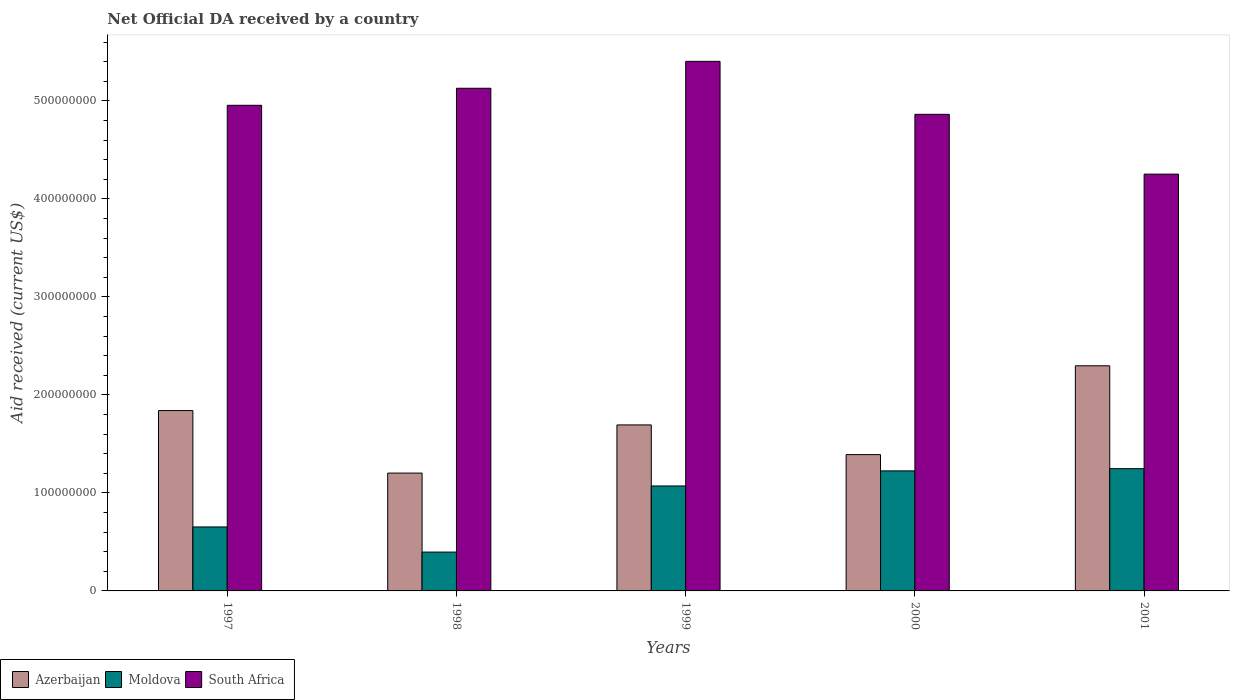Are the number of bars per tick equal to the number of legend labels?
Your response must be concise. Yes. Are the number of bars on each tick of the X-axis equal?
Offer a terse response. Yes. In how many cases, is the number of bars for a given year not equal to the number of legend labels?
Ensure brevity in your answer.  0. What is the net official development assistance aid received in Azerbaijan in 1997?
Provide a succinct answer. 1.84e+08. Across all years, what is the maximum net official development assistance aid received in South Africa?
Offer a very short reply. 5.40e+08. Across all years, what is the minimum net official development assistance aid received in South Africa?
Your answer should be compact. 4.25e+08. What is the total net official development assistance aid received in South Africa in the graph?
Your answer should be very brief. 2.46e+09. What is the difference between the net official development assistance aid received in Moldova in 1999 and that in 2001?
Give a very brief answer. -1.76e+07. What is the difference between the net official development assistance aid received in Moldova in 2001 and the net official development assistance aid received in South Africa in 1999?
Give a very brief answer. -4.16e+08. What is the average net official development assistance aid received in South Africa per year?
Provide a short and direct response. 4.92e+08. In the year 1998, what is the difference between the net official development assistance aid received in South Africa and net official development assistance aid received in Azerbaijan?
Keep it short and to the point. 3.93e+08. What is the ratio of the net official development assistance aid received in South Africa in 1999 to that in 2000?
Your response must be concise. 1.11. Is the net official development assistance aid received in Moldova in 2000 less than that in 2001?
Give a very brief answer. Yes. Is the difference between the net official development assistance aid received in South Africa in 1997 and 2001 greater than the difference between the net official development assistance aid received in Azerbaijan in 1997 and 2001?
Give a very brief answer. Yes. What is the difference between the highest and the second highest net official development assistance aid received in Moldova?
Your response must be concise. 2.26e+06. What is the difference between the highest and the lowest net official development assistance aid received in Azerbaijan?
Your answer should be compact. 1.10e+08. Is the sum of the net official development assistance aid received in Moldova in 1997 and 1999 greater than the maximum net official development assistance aid received in Azerbaijan across all years?
Provide a succinct answer. No. What does the 1st bar from the left in 2001 represents?
Provide a short and direct response. Azerbaijan. What does the 3rd bar from the right in 1999 represents?
Give a very brief answer. Azerbaijan. How many bars are there?
Offer a terse response. 15. Are all the bars in the graph horizontal?
Your answer should be compact. No. How many years are there in the graph?
Offer a terse response. 5. Are the values on the major ticks of Y-axis written in scientific E-notation?
Your answer should be compact. No. Does the graph contain any zero values?
Your answer should be compact. No. What is the title of the graph?
Your answer should be very brief. Net Official DA received by a country. Does "Cabo Verde" appear as one of the legend labels in the graph?
Provide a succinct answer. No. What is the label or title of the X-axis?
Your answer should be very brief. Years. What is the label or title of the Y-axis?
Make the answer very short. Aid received (current US$). What is the Aid received (current US$) in Azerbaijan in 1997?
Provide a succinct answer. 1.84e+08. What is the Aid received (current US$) of Moldova in 1997?
Provide a short and direct response. 6.53e+07. What is the Aid received (current US$) in South Africa in 1997?
Your answer should be compact. 4.96e+08. What is the Aid received (current US$) of Azerbaijan in 1998?
Provide a succinct answer. 1.20e+08. What is the Aid received (current US$) of Moldova in 1998?
Offer a very short reply. 3.96e+07. What is the Aid received (current US$) of South Africa in 1998?
Provide a succinct answer. 5.13e+08. What is the Aid received (current US$) in Azerbaijan in 1999?
Keep it short and to the point. 1.69e+08. What is the Aid received (current US$) of Moldova in 1999?
Your response must be concise. 1.07e+08. What is the Aid received (current US$) of South Africa in 1999?
Offer a very short reply. 5.40e+08. What is the Aid received (current US$) of Azerbaijan in 2000?
Make the answer very short. 1.39e+08. What is the Aid received (current US$) of Moldova in 2000?
Offer a very short reply. 1.22e+08. What is the Aid received (current US$) of South Africa in 2000?
Keep it short and to the point. 4.86e+08. What is the Aid received (current US$) of Azerbaijan in 2001?
Provide a short and direct response. 2.30e+08. What is the Aid received (current US$) in Moldova in 2001?
Your answer should be compact. 1.25e+08. What is the Aid received (current US$) in South Africa in 2001?
Provide a succinct answer. 4.25e+08. Across all years, what is the maximum Aid received (current US$) of Azerbaijan?
Provide a short and direct response. 2.30e+08. Across all years, what is the maximum Aid received (current US$) of Moldova?
Your answer should be compact. 1.25e+08. Across all years, what is the maximum Aid received (current US$) in South Africa?
Make the answer very short. 5.40e+08. Across all years, what is the minimum Aid received (current US$) in Azerbaijan?
Provide a short and direct response. 1.20e+08. Across all years, what is the minimum Aid received (current US$) of Moldova?
Provide a short and direct response. 3.96e+07. Across all years, what is the minimum Aid received (current US$) of South Africa?
Give a very brief answer. 4.25e+08. What is the total Aid received (current US$) of Azerbaijan in the graph?
Provide a short and direct response. 8.43e+08. What is the total Aid received (current US$) in Moldova in the graph?
Make the answer very short. 4.59e+08. What is the total Aid received (current US$) in South Africa in the graph?
Give a very brief answer. 2.46e+09. What is the difference between the Aid received (current US$) in Azerbaijan in 1997 and that in 1998?
Offer a very short reply. 6.38e+07. What is the difference between the Aid received (current US$) of Moldova in 1997 and that in 1998?
Your answer should be compact. 2.57e+07. What is the difference between the Aid received (current US$) of South Africa in 1997 and that in 1998?
Offer a terse response. -1.74e+07. What is the difference between the Aid received (current US$) in Azerbaijan in 1997 and that in 1999?
Make the answer very short. 1.46e+07. What is the difference between the Aid received (current US$) in Moldova in 1997 and that in 1999?
Your response must be concise. -4.18e+07. What is the difference between the Aid received (current US$) in South Africa in 1997 and that in 1999?
Make the answer very short. -4.48e+07. What is the difference between the Aid received (current US$) of Azerbaijan in 1997 and that in 2000?
Offer a very short reply. 4.49e+07. What is the difference between the Aid received (current US$) in Moldova in 1997 and that in 2000?
Your answer should be compact. -5.72e+07. What is the difference between the Aid received (current US$) in South Africa in 1997 and that in 2000?
Keep it short and to the point. 9.22e+06. What is the difference between the Aid received (current US$) in Azerbaijan in 1997 and that in 2001?
Keep it short and to the point. -4.57e+07. What is the difference between the Aid received (current US$) in Moldova in 1997 and that in 2001?
Keep it short and to the point. -5.95e+07. What is the difference between the Aid received (current US$) of South Africa in 1997 and that in 2001?
Make the answer very short. 7.02e+07. What is the difference between the Aid received (current US$) of Azerbaijan in 1998 and that in 1999?
Ensure brevity in your answer.  -4.92e+07. What is the difference between the Aid received (current US$) in Moldova in 1998 and that in 1999?
Your answer should be compact. -6.75e+07. What is the difference between the Aid received (current US$) in South Africa in 1998 and that in 1999?
Provide a succinct answer. -2.75e+07. What is the difference between the Aid received (current US$) in Azerbaijan in 1998 and that in 2000?
Give a very brief answer. -1.89e+07. What is the difference between the Aid received (current US$) of Moldova in 1998 and that in 2000?
Offer a very short reply. -8.29e+07. What is the difference between the Aid received (current US$) of South Africa in 1998 and that in 2000?
Give a very brief answer. 2.66e+07. What is the difference between the Aid received (current US$) of Azerbaijan in 1998 and that in 2001?
Your answer should be compact. -1.10e+08. What is the difference between the Aid received (current US$) of Moldova in 1998 and that in 2001?
Offer a very short reply. -8.51e+07. What is the difference between the Aid received (current US$) in South Africa in 1998 and that in 2001?
Provide a short and direct response. 8.76e+07. What is the difference between the Aid received (current US$) of Azerbaijan in 1999 and that in 2000?
Provide a short and direct response. 3.03e+07. What is the difference between the Aid received (current US$) in Moldova in 1999 and that in 2000?
Keep it short and to the point. -1.54e+07. What is the difference between the Aid received (current US$) of South Africa in 1999 and that in 2000?
Offer a very short reply. 5.41e+07. What is the difference between the Aid received (current US$) of Azerbaijan in 1999 and that in 2001?
Offer a very short reply. -6.03e+07. What is the difference between the Aid received (current US$) in Moldova in 1999 and that in 2001?
Provide a succinct answer. -1.76e+07. What is the difference between the Aid received (current US$) of South Africa in 1999 and that in 2001?
Offer a terse response. 1.15e+08. What is the difference between the Aid received (current US$) in Azerbaijan in 2000 and that in 2001?
Provide a short and direct response. -9.06e+07. What is the difference between the Aid received (current US$) of Moldova in 2000 and that in 2001?
Your response must be concise. -2.26e+06. What is the difference between the Aid received (current US$) of South Africa in 2000 and that in 2001?
Your response must be concise. 6.10e+07. What is the difference between the Aid received (current US$) in Azerbaijan in 1997 and the Aid received (current US$) in Moldova in 1998?
Your answer should be very brief. 1.44e+08. What is the difference between the Aid received (current US$) in Azerbaijan in 1997 and the Aid received (current US$) in South Africa in 1998?
Ensure brevity in your answer.  -3.29e+08. What is the difference between the Aid received (current US$) in Moldova in 1997 and the Aid received (current US$) in South Africa in 1998?
Give a very brief answer. -4.48e+08. What is the difference between the Aid received (current US$) in Azerbaijan in 1997 and the Aid received (current US$) in Moldova in 1999?
Offer a terse response. 7.70e+07. What is the difference between the Aid received (current US$) of Azerbaijan in 1997 and the Aid received (current US$) of South Africa in 1999?
Make the answer very short. -3.56e+08. What is the difference between the Aid received (current US$) in Moldova in 1997 and the Aid received (current US$) in South Africa in 1999?
Give a very brief answer. -4.75e+08. What is the difference between the Aid received (current US$) in Azerbaijan in 1997 and the Aid received (current US$) in Moldova in 2000?
Provide a short and direct response. 6.16e+07. What is the difference between the Aid received (current US$) in Azerbaijan in 1997 and the Aid received (current US$) in South Africa in 2000?
Keep it short and to the point. -3.02e+08. What is the difference between the Aid received (current US$) in Moldova in 1997 and the Aid received (current US$) in South Africa in 2000?
Provide a short and direct response. -4.21e+08. What is the difference between the Aid received (current US$) of Azerbaijan in 1997 and the Aid received (current US$) of Moldova in 2001?
Your response must be concise. 5.93e+07. What is the difference between the Aid received (current US$) in Azerbaijan in 1997 and the Aid received (current US$) in South Africa in 2001?
Your answer should be very brief. -2.41e+08. What is the difference between the Aid received (current US$) of Moldova in 1997 and the Aid received (current US$) of South Africa in 2001?
Your response must be concise. -3.60e+08. What is the difference between the Aid received (current US$) in Azerbaijan in 1998 and the Aid received (current US$) in Moldova in 1999?
Make the answer very short. 1.31e+07. What is the difference between the Aid received (current US$) of Azerbaijan in 1998 and the Aid received (current US$) of South Africa in 1999?
Offer a terse response. -4.20e+08. What is the difference between the Aid received (current US$) of Moldova in 1998 and the Aid received (current US$) of South Africa in 1999?
Ensure brevity in your answer.  -5.01e+08. What is the difference between the Aid received (current US$) of Azerbaijan in 1998 and the Aid received (current US$) of Moldova in 2000?
Keep it short and to the point. -2.25e+06. What is the difference between the Aid received (current US$) of Azerbaijan in 1998 and the Aid received (current US$) of South Africa in 2000?
Offer a terse response. -3.66e+08. What is the difference between the Aid received (current US$) of Moldova in 1998 and the Aid received (current US$) of South Africa in 2000?
Provide a succinct answer. -4.47e+08. What is the difference between the Aid received (current US$) in Azerbaijan in 1998 and the Aid received (current US$) in Moldova in 2001?
Provide a short and direct response. -4.51e+06. What is the difference between the Aid received (current US$) of Azerbaijan in 1998 and the Aid received (current US$) of South Africa in 2001?
Your answer should be compact. -3.05e+08. What is the difference between the Aid received (current US$) of Moldova in 1998 and the Aid received (current US$) of South Africa in 2001?
Your answer should be compact. -3.86e+08. What is the difference between the Aid received (current US$) in Azerbaijan in 1999 and the Aid received (current US$) in Moldova in 2000?
Make the answer very short. 4.69e+07. What is the difference between the Aid received (current US$) in Azerbaijan in 1999 and the Aid received (current US$) in South Africa in 2000?
Offer a terse response. -3.17e+08. What is the difference between the Aid received (current US$) in Moldova in 1999 and the Aid received (current US$) in South Africa in 2000?
Your response must be concise. -3.79e+08. What is the difference between the Aid received (current US$) in Azerbaijan in 1999 and the Aid received (current US$) in Moldova in 2001?
Your answer should be compact. 4.47e+07. What is the difference between the Aid received (current US$) of Azerbaijan in 1999 and the Aid received (current US$) of South Africa in 2001?
Give a very brief answer. -2.56e+08. What is the difference between the Aid received (current US$) in Moldova in 1999 and the Aid received (current US$) in South Africa in 2001?
Make the answer very short. -3.18e+08. What is the difference between the Aid received (current US$) of Azerbaijan in 2000 and the Aid received (current US$) of Moldova in 2001?
Make the answer very short. 1.44e+07. What is the difference between the Aid received (current US$) of Azerbaijan in 2000 and the Aid received (current US$) of South Africa in 2001?
Keep it short and to the point. -2.86e+08. What is the difference between the Aid received (current US$) in Moldova in 2000 and the Aid received (current US$) in South Africa in 2001?
Make the answer very short. -3.03e+08. What is the average Aid received (current US$) in Azerbaijan per year?
Your response must be concise. 1.69e+08. What is the average Aid received (current US$) of Moldova per year?
Your answer should be very brief. 9.19e+07. What is the average Aid received (current US$) in South Africa per year?
Give a very brief answer. 4.92e+08. In the year 1997, what is the difference between the Aid received (current US$) in Azerbaijan and Aid received (current US$) in Moldova?
Offer a very short reply. 1.19e+08. In the year 1997, what is the difference between the Aid received (current US$) in Azerbaijan and Aid received (current US$) in South Africa?
Your answer should be compact. -3.12e+08. In the year 1997, what is the difference between the Aid received (current US$) of Moldova and Aid received (current US$) of South Africa?
Your answer should be compact. -4.30e+08. In the year 1998, what is the difference between the Aid received (current US$) of Azerbaijan and Aid received (current US$) of Moldova?
Give a very brief answer. 8.06e+07. In the year 1998, what is the difference between the Aid received (current US$) in Azerbaijan and Aid received (current US$) in South Africa?
Offer a terse response. -3.93e+08. In the year 1998, what is the difference between the Aid received (current US$) in Moldova and Aid received (current US$) in South Africa?
Provide a succinct answer. -4.73e+08. In the year 1999, what is the difference between the Aid received (current US$) in Azerbaijan and Aid received (current US$) in Moldova?
Offer a terse response. 6.23e+07. In the year 1999, what is the difference between the Aid received (current US$) in Azerbaijan and Aid received (current US$) in South Africa?
Provide a succinct answer. -3.71e+08. In the year 1999, what is the difference between the Aid received (current US$) in Moldova and Aid received (current US$) in South Africa?
Provide a succinct answer. -4.33e+08. In the year 2000, what is the difference between the Aid received (current US$) of Azerbaijan and Aid received (current US$) of Moldova?
Offer a terse response. 1.66e+07. In the year 2000, what is the difference between the Aid received (current US$) in Azerbaijan and Aid received (current US$) in South Africa?
Your response must be concise. -3.47e+08. In the year 2000, what is the difference between the Aid received (current US$) in Moldova and Aid received (current US$) in South Africa?
Your answer should be compact. -3.64e+08. In the year 2001, what is the difference between the Aid received (current US$) in Azerbaijan and Aid received (current US$) in Moldova?
Your response must be concise. 1.05e+08. In the year 2001, what is the difference between the Aid received (current US$) in Azerbaijan and Aid received (current US$) in South Africa?
Provide a short and direct response. -1.96e+08. In the year 2001, what is the difference between the Aid received (current US$) of Moldova and Aid received (current US$) of South Africa?
Provide a succinct answer. -3.01e+08. What is the ratio of the Aid received (current US$) of Azerbaijan in 1997 to that in 1998?
Provide a short and direct response. 1.53. What is the ratio of the Aid received (current US$) of Moldova in 1997 to that in 1998?
Provide a succinct answer. 1.65. What is the ratio of the Aid received (current US$) in South Africa in 1997 to that in 1998?
Ensure brevity in your answer.  0.97. What is the ratio of the Aid received (current US$) of Azerbaijan in 1997 to that in 1999?
Offer a very short reply. 1.09. What is the ratio of the Aid received (current US$) of Moldova in 1997 to that in 1999?
Keep it short and to the point. 0.61. What is the ratio of the Aid received (current US$) of South Africa in 1997 to that in 1999?
Provide a succinct answer. 0.92. What is the ratio of the Aid received (current US$) in Azerbaijan in 1997 to that in 2000?
Keep it short and to the point. 1.32. What is the ratio of the Aid received (current US$) in Moldova in 1997 to that in 2000?
Your answer should be compact. 0.53. What is the ratio of the Aid received (current US$) in South Africa in 1997 to that in 2000?
Offer a terse response. 1.02. What is the ratio of the Aid received (current US$) of Azerbaijan in 1997 to that in 2001?
Your answer should be compact. 0.8. What is the ratio of the Aid received (current US$) in Moldova in 1997 to that in 2001?
Make the answer very short. 0.52. What is the ratio of the Aid received (current US$) in South Africa in 1997 to that in 2001?
Offer a terse response. 1.17. What is the ratio of the Aid received (current US$) of Azerbaijan in 1998 to that in 1999?
Make the answer very short. 0.71. What is the ratio of the Aid received (current US$) in Moldova in 1998 to that in 1999?
Provide a short and direct response. 0.37. What is the ratio of the Aid received (current US$) in South Africa in 1998 to that in 1999?
Make the answer very short. 0.95. What is the ratio of the Aid received (current US$) of Azerbaijan in 1998 to that in 2000?
Make the answer very short. 0.86. What is the ratio of the Aid received (current US$) in Moldova in 1998 to that in 2000?
Make the answer very short. 0.32. What is the ratio of the Aid received (current US$) in South Africa in 1998 to that in 2000?
Offer a terse response. 1.05. What is the ratio of the Aid received (current US$) of Azerbaijan in 1998 to that in 2001?
Give a very brief answer. 0.52. What is the ratio of the Aid received (current US$) of Moldova in 1998 to that in 2001?
Provide a succinct answer. 0.32. What is the ratio of the Aid received (current US$) of South Africa in 1998 to that in 2001?
Provide a short and direct response. 1.21. What is the ratio of the Aid received (current US$) in Azerbaijan in 1999 to that in 2000?
Give a very brief answer. 1.22. What is the ratio of the Aid received (current US$) in Moldova in 1999 to that in 2000?
Provide a short and direct response. 0.87. What is the ratio of the Aid received (current US$) in South Africa in 1999 to that in 2000?
Provide a succinct answer. 1.11. What is the ratio of the Aid received (current US$) in Azerbaijan in 1999 to that in 2001?
Give a very brief answer. 0.74. What is the ratio of the Aid received (current US$) of Moldova in 1999 to that in 2001?
Ensure brevity in your answer.  0.86. What is the ratio of the Aid received (current US$) in South Africa in 1999 to that in 2001?
Your answer should be very brief. 1.27. What is the ratio of the Aid received (current US$) of Azerbaijan in 2000 to that in 2001?
Your response must be concise. 0.61. What is the ratio of the Aid received (current US$) in Moldova in 2000 to that in 2001?
Give a very brief answer. 0.98. What is the ratio of the Aid received (current US$) in South Africa in 2000 to that in 2001?
Your response must be concise. 1.14. What is the difference between the highest and the second highest Aid received (current US$) of Azerbaijan?
Provide a succinct answer. 4.57e+07. What is the difference between the highest and the second highest Aid received (current US$) in Moldova?
Provide a succinct answer. 2.26e+06. What is the difference between the highest and the second highest Aid received (current US$) of South Africa?
Keep it short and to the point. 2.75e+07. What is the difference between the highest and the lowest Aid received (current US$) of Azerbaijan?
Provide a short and direct response. 1.10e+08. What is the difference between the highest and the lowest Aid received (current US$) of Moldova?
Ensure brevity in your answer.  8.51e+07. What is the difference between the highest and the lowest Aid received (current US$) of South Africa?
Provide a succinct answer. 1.15e+08. 